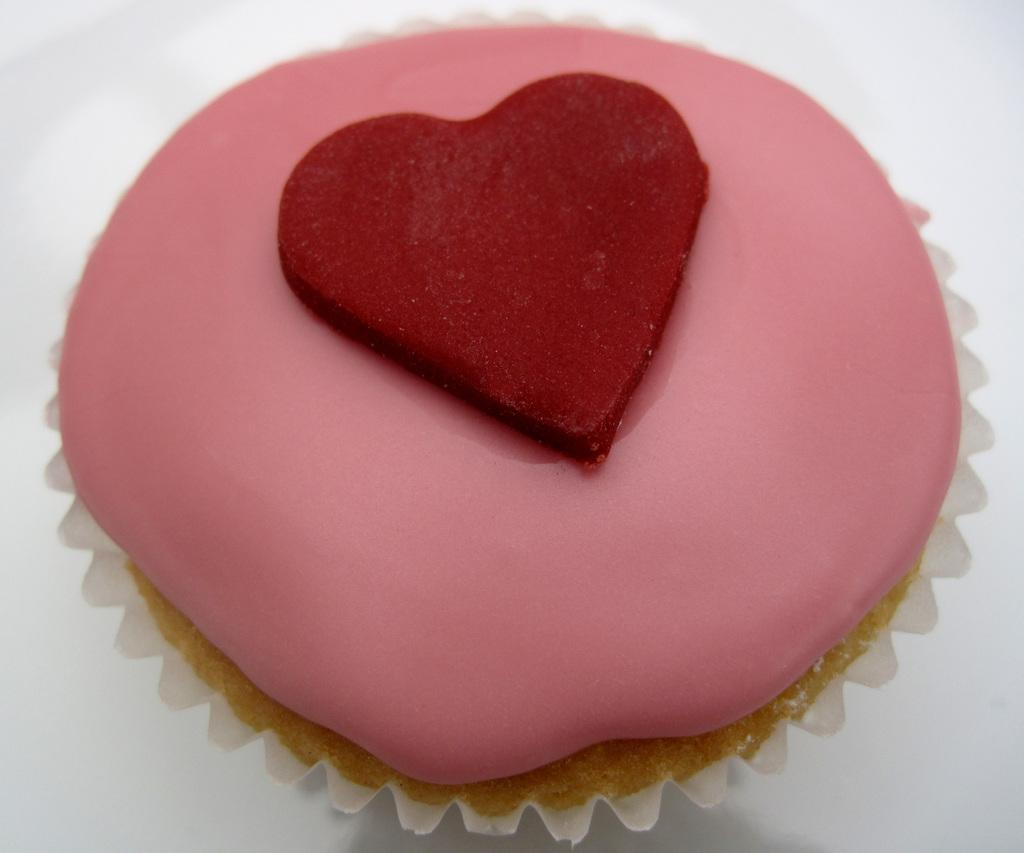What color is the muffin in the image? The muffin in the image is pink. What decoration is on the muffin? There is a red heart on the muffin. On what surface is the muffin placed? The muffin is placed on a white surface. Where is the playground located in the image? There is no playground present in the image. What type of grape is used to decorate the muffin? There are no grapes used to decorate the muffin; it has a red heart instead. 